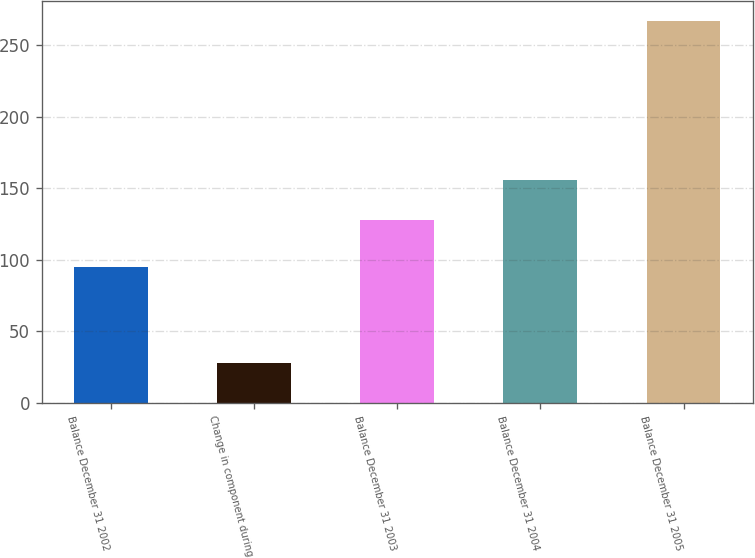Convert chart to OTSL. <chart><loc_0><loc_0><loc_500><loc_500><bar_chart><fcel>Balance December 31 2002<fcel>Change in component during<fcel>Balance December 31 2003<fcel>Balance December 31 2004<fcel>Balance December 31 2005<nl><fcel>95<fcel>28<fcel>128<fcel>156<fcel>267<nl></chart> 